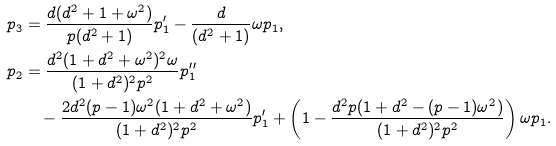<formula> <loc_0><loc_0><loc_500><loc_500>p _ { 3 } & = \frac { d ( d ^ { 2 } + 1 + \omega ^ { 2 } ) } { p ( d ^ { 2 } + 1 ) } p _ { 1 } ^ { \prime } - \frac { d } { ( d ^ { 2 } + 1 ) } \omega p _ { 1 } , \\ p _ { 2 } & = \frac { d ^ { 2 } ( 1 + d ^ { 2 } + \omega ^ { 2 } ) ^ { 2 } \omega } { ( 1 + d ^ { 2 } ) ^ { 2 } p ^ { 2 } } p _ { 1 } ^ { \prime \prime } \\ & \quad - \frac { 2 d ^ { 2 } ( p - 1 ) \omega ^ { 2 } ( 1 + d ^ { 2 } + \omega ^ { 2 } ) } { ( 1 + d ^ { 2 } ) ^ { 2 } p ^ { 2 } } p _ { 1 } ^ { \prime } + \left ( 1 - \frac { d ^ { 2 } p ( 1 + d ^ { 2 } - ( p - 1 ) \omega ^ { 2 } ) } { ( 1 + d ^ { 2 } ) ^ { 2 } p ^ { 2 } } \right ) \omega p _ { 1 } .</formula> 